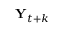<formula> <loc_0><loc_0><loc_500><loc_500>Y _ { t + k }</formula> 